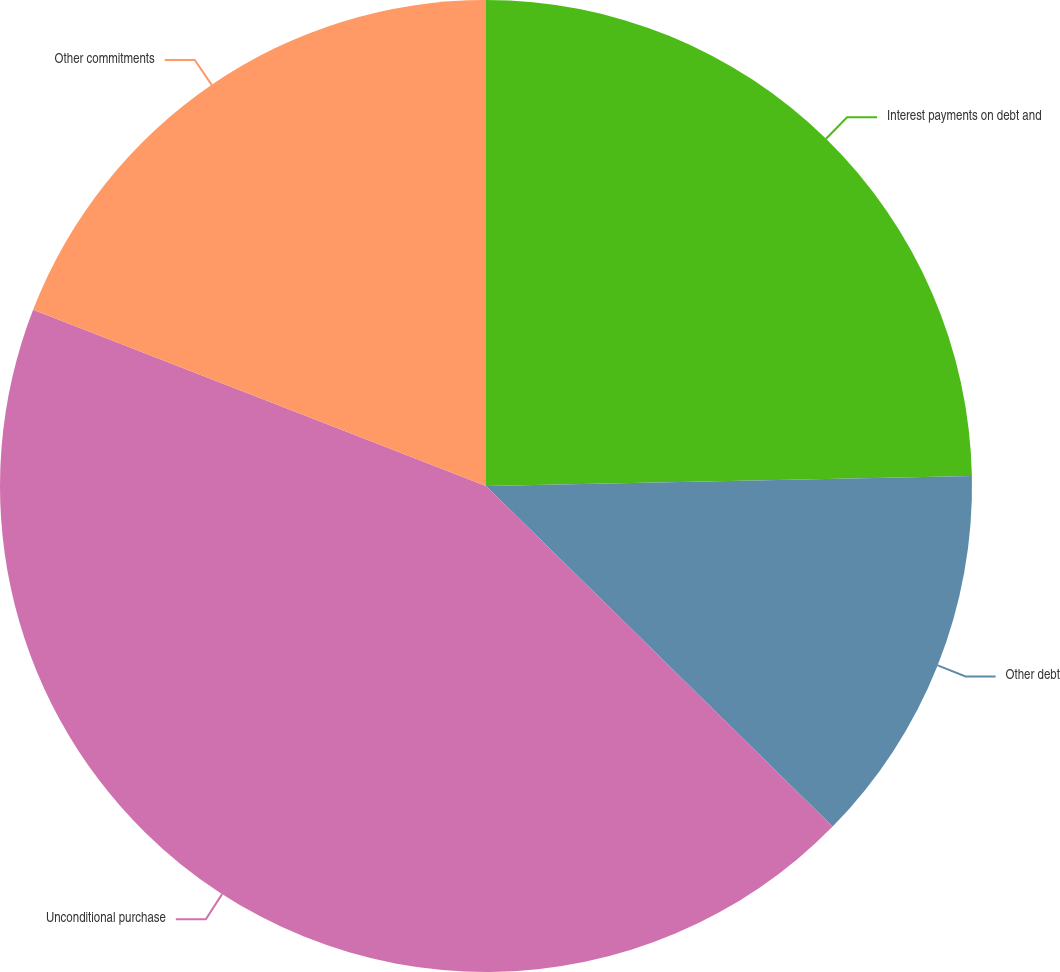<chart> <loc_0><loc_0><loc_500><loc_500><pie_chart><fcel>Interest payments on debt and<fcel>Other debt<fcel>Unconditional purchase<fcel>Other commitments<nl><fcel>24.67%<fcel>12.69%<fcel>43.55%<fcel>19.09%<nl></chart> 